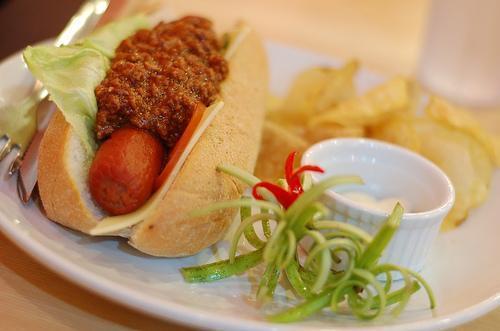Evaluate: Does the caption "The bowl is next to the hot dog." match the image?
Answer yes or no. Yes. 